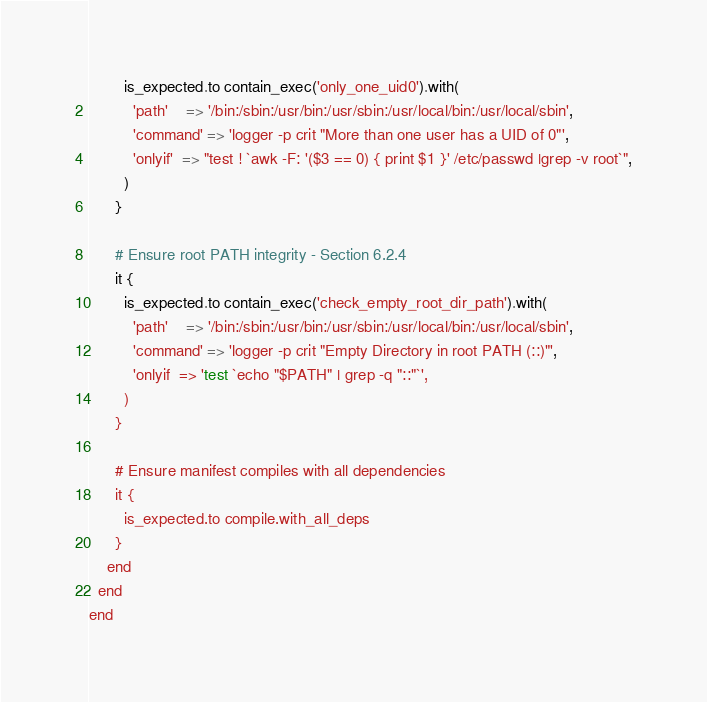Convert code to text. <code><loc_0><loc_0><loc_500><loc_500><_Ruby_>        is_expected.to contain_exec('only_one_uid0').with(
          'path'    => '/bin:/sbin:/usr/bin:/usr/sbin:/usr/local/bin:/usr/local/sbin',
          'command' => 'logger -p crit "More than one user has a UID of 0"',
          'onlyif'  => "test ! `awk -F: '($3 == 0) { print $1 }' /etc/passwd |grep -v root`",
        )
      }

      # Ensure root PATH integrity - Section 6.2.4
      it {
        is_expected.to contain_exec('check_empty_root_dir_path').with(
          'path'    => '/bin:/sbin:/usr/bin:/usr/sbin:/usr/local/bin:/usr/local/sbin',
          'command' => 'logger -p crit "Empty Directory in root PATH (::)"',
          'onlyif  => 'test `echo "$PATH" | grep -q "::"`',
        )
      }

      # Ensure manifest compiles with all dependencies
      it {
        is_expected.to compile.with_all_deps
      }
    end
  end
end
</code> 